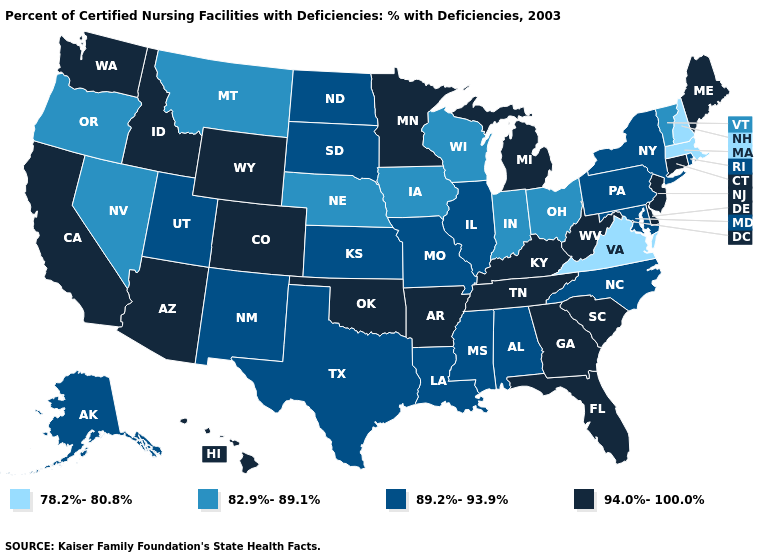Does the first symbol in the legend represent the smallest category?
Answer briefly. Yes. Does Virginia have the lowest value in the USA?
Concise answer only. Yes. What is the value of Ohio?
Keep it brief. 82.9%-89.1%. Name the states that have a value in the range 82.9%-89.1%?
Keep it brief. Indiana, Iowa, Montana, Nebraska, Nevada, Ohio, Oregon, Vermont, Wisconsin. Does the first symbol in the legend represent the smallest category?
Quick response, please. Yes. Name the states that have a value in the range 82.9%-89.1%?
Short answer required. Indiana, Iowa, Montana, Nebraska, Nevada, Ohio, Oregon, Vermont, Wisconsin. Name the states that have a value in the range 89.2%-93.9%?
Keep it brief. Alabama, Alaska, Illinois, Kansas, Louisiana, Maryland, Mississippi, Missouri, New Mexico, New York, North Carolina, North Dakota, Pennsylvania, Rhode Island, South Dakota, Texas, Utah. Does Connecticut have the lowest value in the Northeast?
Answer briefly. No. Which states have the lowest value in the Northeast?
Keep it brief. Massachusetts, New Hampshire. Which states hav the highest value in the West?
Write a very short answer. Arizona, California, Colorado, Hawaii, Idaho, Washington, Wyoming. What is the value of Maryland?
Write a very short answer. 89.2%-93.9%. Among the states that border Nebraska , which have the lowest value?
Keep it brief. Iowa. Which states have the highest value in the USA?
Be succinct. Arizona, Arkansas, California, Colorado, Connecticut, Delaware, Florida, Georgia, Hawaii, Idaho, Kentucky, Maine, Michigan, Minnesota, New Jersey, Oklahoma, South Carolina, Tennessee, Washington, West Virginia, Wyoming. Among the states that border Maryland , does Delaware have the lowest value?
Write a very short answer. No. What is the value of Montana?
Answer briefly. 82.9%-89.1%. 